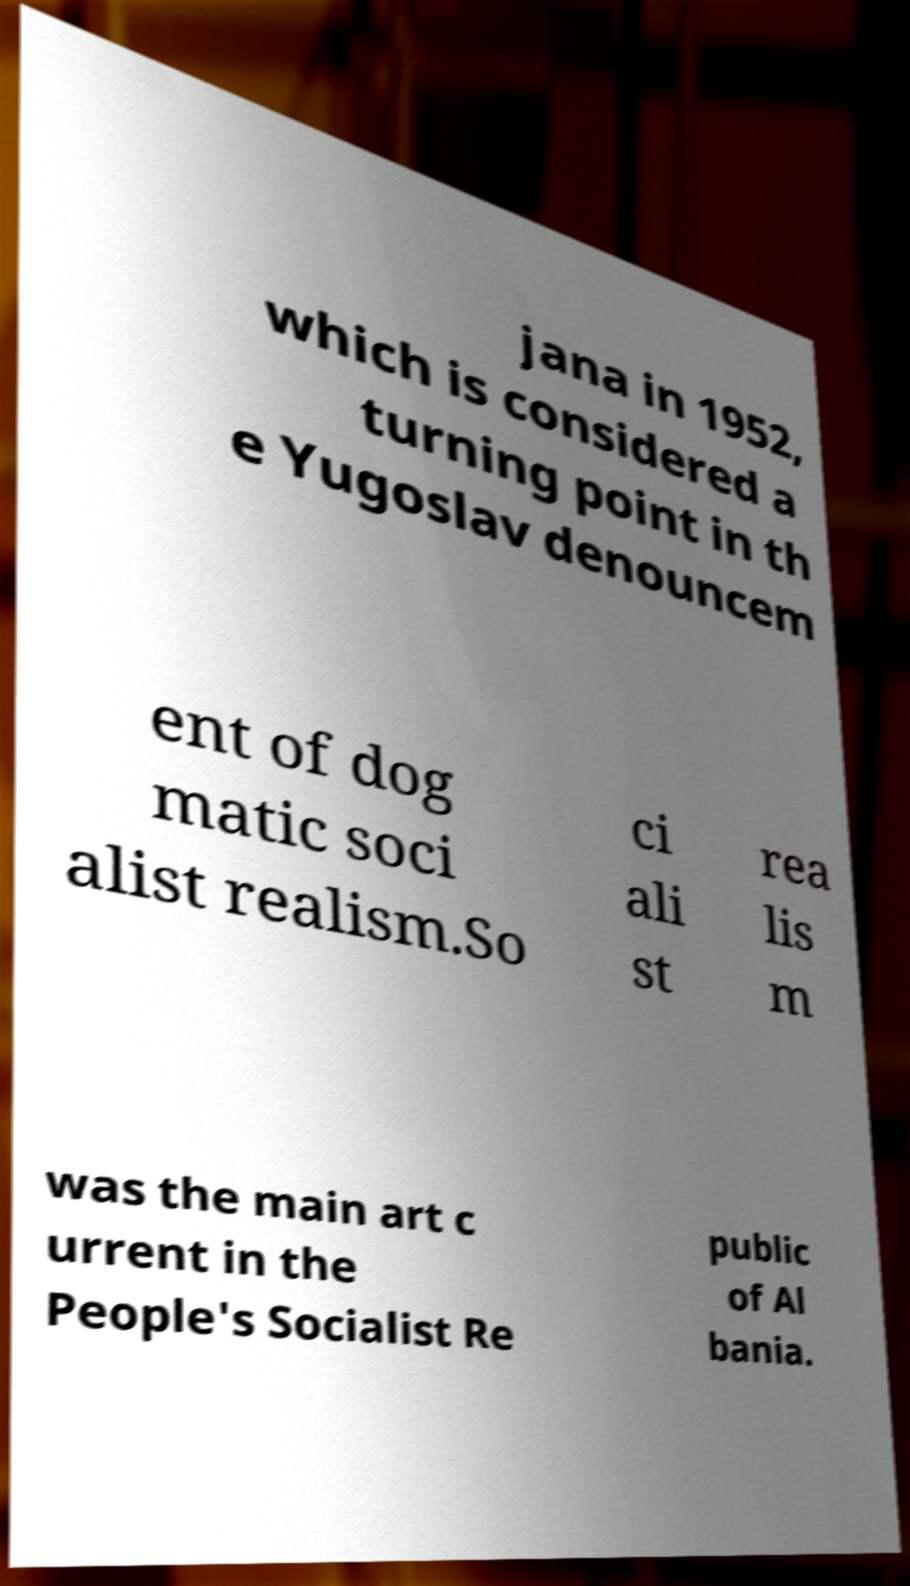Could you extract and type out the text from this image? jana in 1952, which is considered a turning point in th e Yugoslav denouncem ent of dog matic soci alist realism.So ci ali st rea lis m was the main art c urrent in the People's Socialist Re public of Al bania. 